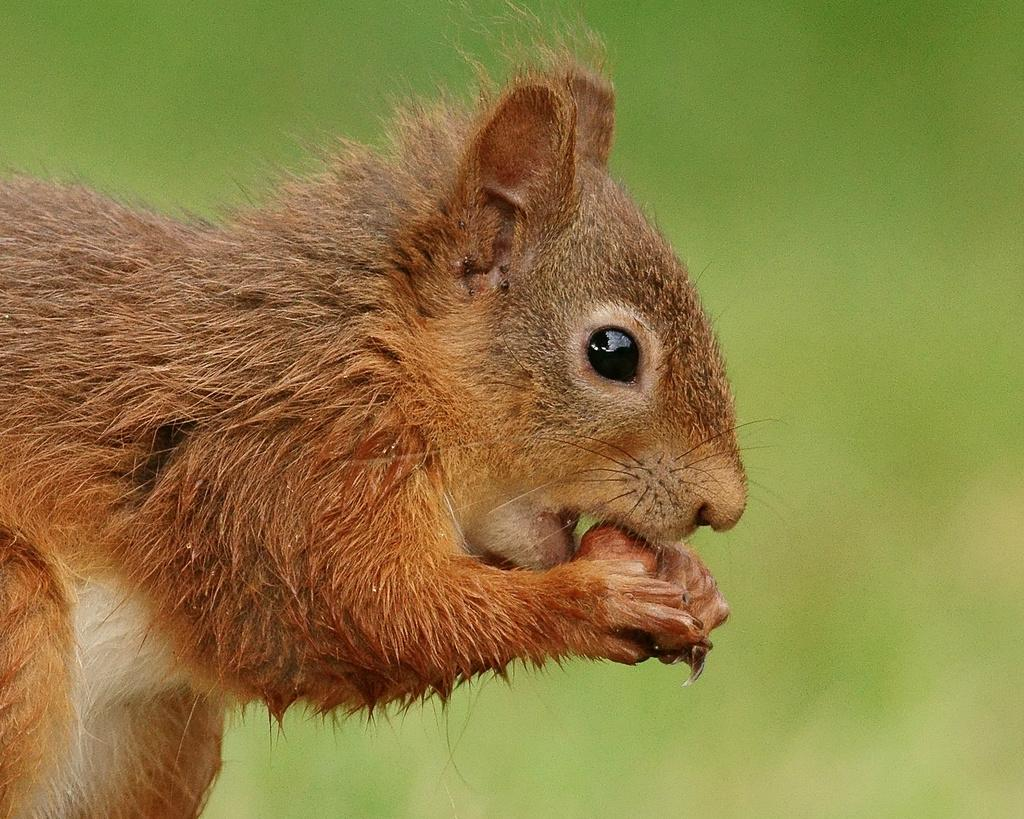What type of animal is in the image? There is a squirrel in the image. What is the squirrel holding in its hands? The squirrel is holding a brown object in its hands. Can you describe the background of the image? The background of the image is blurry. What type of rhythm does the squirrel play on the horn in the image? There is no horn present in the image, and therefore no rhythm being played. 